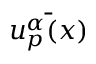<formula> <loc_0><loc_0><loc_500><loc_500>\bar { u _ { p } ^ { \alpha } ( x ) }</formula> 